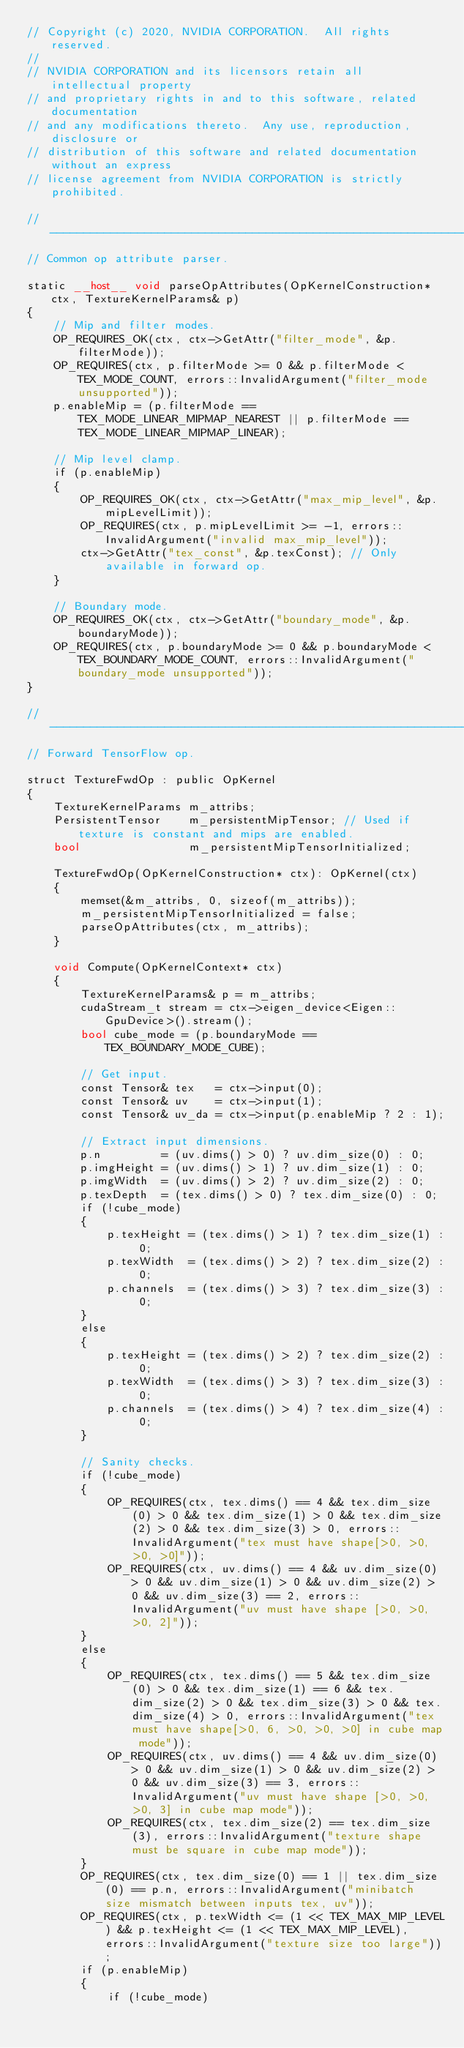Convert code to text. <code><loc_0><loc_0><loc_500><loc_500><_Cuda_>// Copyright (c) 2020, NVIDIA CORPORATION.  All rights reserved.
//
// NVIDIA CORPORATION and its licensors retain all intellectual property
// and proprietary rights in and to this software, related documentation
// and any modifications thereto.  Any use, reproduction, disclosure or
// distribution of this software and related documentation without an express
// license agreement from NVIDIA CORPORATION is strictly prohibited.

//------------------------------------------------------------------------
// Common op attribute parser.

static __host__ void parseOpAttributes(OpKernelConstruction* ctx, TextureKernelParams& p)
{
    // Mip and filter modes.
    OP_REQUIRES_OK(ctx, ctx->GetAttr("filter_mode", &p.filterMode));
    OP_REQUIRES(ctx, p.filterMode >= 0 && p.filterMode < TEX_MODE_COUNT, errors::InvalidArgument("filter_mode unsupported"));
    p.enableMip = (p.filterMode == TEX_MODE_LINEAR_MIPMAP_NEAREST || p.filterMode == TEX_MODE_LINEAR_MIPMAP_LINEAR);

    // Mip level clamp.
    if (p.enableMip)
    {
        OP_REQUIRES_OK(ctx, ctx->GetAttr("max_mip_level", &p.mipLevelLimit));
        OP_REQUIRES(ctx, p.mipLevelLimit >= -1, errors::InvalidArgument("invalid max_mip_level"));
        ctx->GetAttr("tex_const", &p.texConst); // Only available in forward op.
    }

    // Boundary mode.
    OP_REQUIRES_OK(ctx, ctx->GetAttr("boundary_mode", &p.boundaryMode));
    OP_REQUIRES(ctx, p.boundaryMode >= 0 && p.boundaryMode < TEX_BOUNDARY_MODE_COUNT, errors::InvalidArgument("boundary_mode unsupported"));
}

//------------------------------------------------------------------------
// Forward TensorFlow op.

struct TextureFwdOp : public OpKernel
{
    TextureKernelParams m_attribs;
    PersistentTensor    m_persistentMipTensor; // Used if texture is constant and mips are enabled.
    bool                m_persistentMipTensorInitialized;

    TextureFwdOp(OpKernelConstruction* ctx): OpKernel(ctx)
    {
        memset(&m_attribs, 0, sizeof(m_attribs));
        m_persistentMipTensorInitialized = false;
        parseOpAttributes(ctx, m_attribs);
    }

    void Compute(OpKernelContext* ctx)
    {
        TextureKernelParams& p = m_attribs;
        cudaStream_t stream = ctx->eigen_device<Eigen::GpuDevice>().stream();
        bool cube_mode = (p.boundaryMode == TEX_BOUNDARY_MODE_CUBE);

        // Get input.
        const Tensor& tex   = ctx->input(0);
        const Tensor& uv    = ctx->input(1);
        const Tensor& uv_da = ctx->input(p.enableMip ? 2 : 1);

        // Extract input dimensions.
        p.n         = (uv.dims() > 0) ? uv.dim_size(0) : 0;
        p.imgHeight = (uv.dims() > 1) ? uv.dim_size(1) : 0;
        p.imgWidth  = (uv.dims() > 2) ? uv.dim_size(2) : 0;
        p.texDepth  = (tex.dims() > 0) ? tex.dim_size(0) : 0;
        if (!cube_mode)
        {
            p.texHeight = (tex.dims() > 1) ? tex.dim_size(1) : 0;
            p.texWidth  = (tex.dims() > 2) ? tex.dim_size(2) : 0;
            p.channels  = (tex.dims() > 3) ? tex.dim_size(3) : 0;
        }
        else
        {
            p.texHeight = (tex.dims() > 2) ? tex.dim_size(2) : 0;
            p.texWidth  = (tex.dims() > 3) ? tex.dim_size(3) : 0;
            p.channels  = (tex.dims() > 4) ? tex.dim_size(4) : 0;
        }

        // Sanity checks.
        if (!cube_mode)
        {
            OP_REQUIRES(ctx, tex.dims() == 4 && tex.dim_size(0) > 0 && tex.dim_size(1) > 0 && tex.dim_size(2) > 0 && tex.dim_size(3) > 0, errors::InvalidArgument("tex must have shape[>0, >0, >0, >0]"));
            OP_REQUIRES(ctx, uv.dims() == 4 && uv.dim_size(0) > 0 && uv.dim_size(1) > 0 && uv.dim_size(2) > 0 && uv.dim_size(3) == 2, errors::InvalidArgument("uv must have shape [>0, >0, >0, 2]"));
        }
        else
        {
            OP_REQUIRES(ctx, tex.dims() == 5 && tex.dim_size(0) > 0 && tex.dim_size(1) == 6 && tex.dim_size(2) > 0 && tex.dim_size(3) > 0 && tex.dim_size(4) > 0, errors::InvalidArgument("tex must have shape[>0, 6, >0, >0, >0] in cube map mode"));
            OP_REQUIRES(ctx, uv.dims() == 4 && uv.dim_size(0) > 0 && uv.dim_size(1) > 0 && uv.dim_size(2) > 0 && uv.dim_size(3) == 3, errors::InvalidArgument("uv must have shape [>0, >0, >0, 3] in cube map mode"));
            OP_REQUIRES(ctx, tex.dim_size(2) == tex.dim_size(3), errors::InvalidArgument("texture shape must be square in cube map mode"));
        }
        OP_REQUIRES(ctx, tex.dim_size(0) == 1 || tex.dim_size(0) == p.n, errors::InvalidArgument("minibatch size mismatch between inputs tex, uv"));
        OP_REQUIRES(ctx, p.texWidth <= (1 << TEX_MAX_MIP_LEVEL) && p.texHeight <= (1 << TEX_MAX_MIP_LEVEL), errors::InvalidArgument("texture size too large"));
        if (p.enableMip)
        {
            if (!cube_mode)</code> 